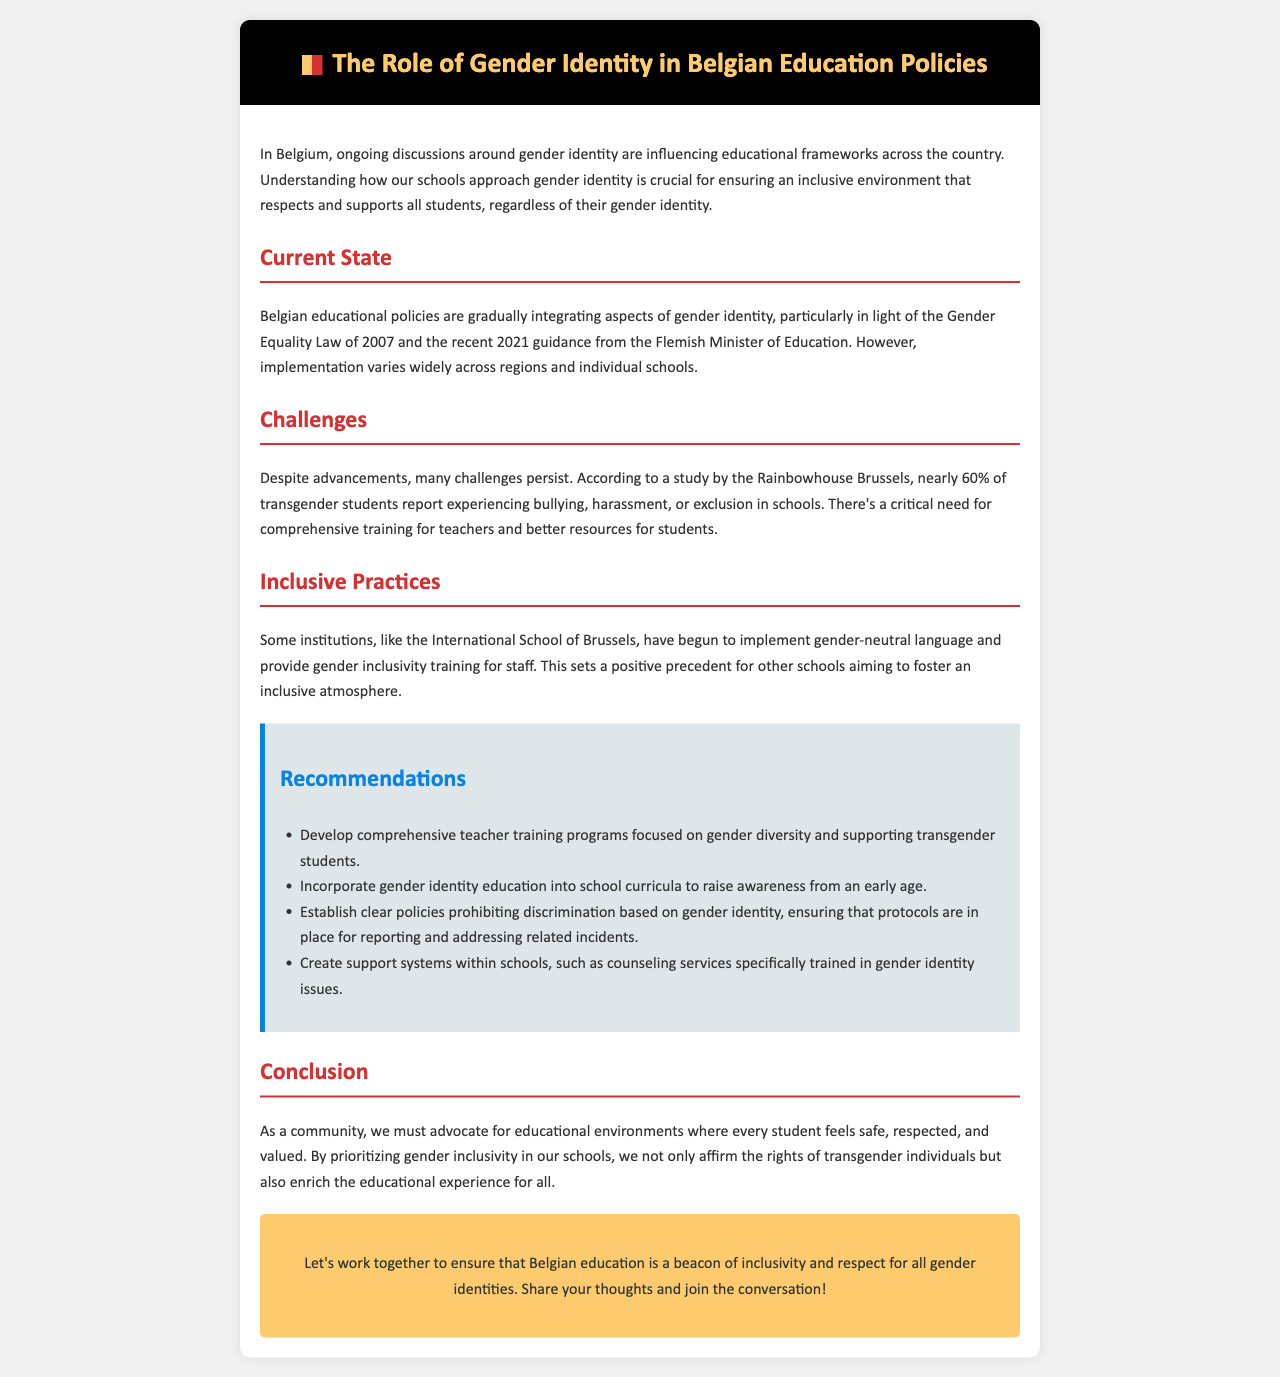What is the title of the newsletter? The title of the newsletter is mentioned at the top, detailing the focus on gender identity in Belgian education policies.
Answer: The Role of Gender Identity in Belgian Education Policies What year was the Gender Equality Law enacted? The document highlights the Gender Equality Law of 2007, which is a key point in the context of gender identity discussions in education.
Answer: 2007 What percentage of transgender students report experiencing bullying? According to a study by the Rainbowhouse Brussels, this percentage reflects a significant issue within schools regarding the treatment of transgender students.
Answer: 60% Which school is mentioned as implementing gender-neutral language? The International School of Brussels is cited as an example of positive practices in fostering an inclusive educational environment.
Answer: International School of Brussels What is one of the recommendations for teacher training? The recommendations in the document suggest various approaches to improve support for transgender students, specifically focusing on education for teachers.
Answer: Focused on gender diversity What is a critical need identified in the challenges section? The challenges faced in Belgian education regarding gender identity emphasize the necessity for additional support systems for both teachers and students.
Answer: Comprehensive training What type of document is this? The structure and purpose of the newsletter indicate its role in informing and advocating for policies related to gender identity in education.
Answer: Newsletter What is the background color of the call-to-action section? The call-to-action section is visually distinct with a specific background color that underscores its importance in the document.
Answer: #fdcb6e 